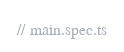Convert code to text. <code><loc_0><loc_0><loc_500><loc_500><_TypeScript_>// main.spec.ts
</code> 